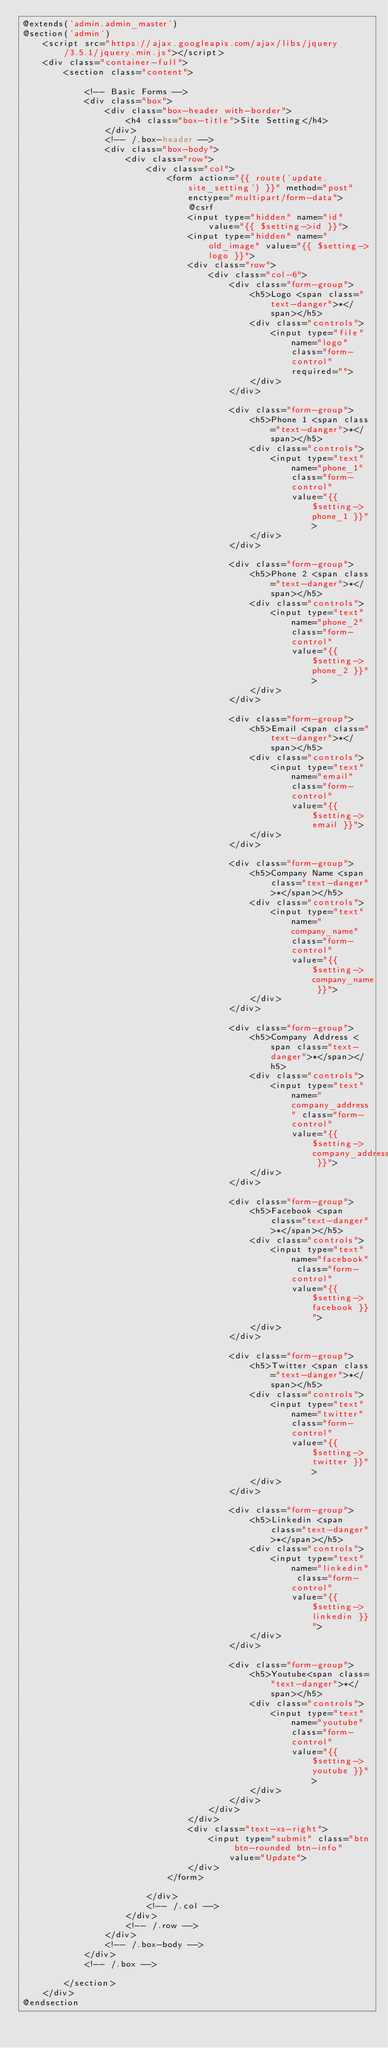<code> <loc_0><loc_0><loc_500><loc_500><_PHP_>@extends('admin.admin_master')
@section('admin')
    <script src="https://ajax.googleapis.com/ajax/libs/jquery/3.5.1/jquery.min.js"></script>
    <div class="container-full">
        <section class="content">

            <!-- Basic Forms -->
            <div class="box">
                <div class="box-header with-border">
                    <h4 class="box-title">Site Setting</h4>
                </div>
                <!-- /.box-header -->
                <div class="box-body">
                    <div class="row">
                        <div class="col">
                            <form action="{{ route('update.site_setting') }}" method="post" enctype="multipart/form-data">
                                @csrf
                                <input type="hidden" name="id" value="{{ $setting->id }}">
                                <input type="hidden" name="old_image" value="{{ $setting->logo }}">
                                <div class="row">
                                    <div class="col-6">
                                        <div class="form-group">
                                            <h5>Logo <span class="text-danger">*</span></h5>
                                            <div class="controls">
                                                <input type="file" name="logo" class="form-control" required="">
                                            </div>
                                        </div>

                                        <div class="form-group">
                                            <h5>Phone 1 <span class="text-danger">*</span></h5>
                                            <div class="controls">
                                                <input type="text" name="phone_1" class="form-control"
                                                    value="{{ $setting->phone_1 }}">
                                            </div>
                                        </div>

                                        <div class="form-group">
                                            <h5>Phone 2 <span class="text-danger">*</span></h5>
                                            <div class="controls">
                                                <input type="text" name="phone_2" class="form-control"
                                                    value="{{ $setting->phone_2 }}">
                                            </div>
                                        </div>

                                        <div class="form-group">
                                            <h5>Email <span class="text-danger">*</span></h5>
                                            <div class="controls">
                                                <input type="text" name="email" class="form-control"
                                                    value="{{ $setting->email }}">
                                            </div>
                                        </div>

                                        <div class="form-group">
                                            <h5>Company Name <span class="text-danger">*</span></h5>
                                            <div class="controls">
                                                <input type="text" name="company_name" class="form-control"
                                                    value="{{ $setting->company_name }}">
                                            </div>
                                        </div>

                                        <div class="form-group">
                                            <h5>Company Address <span class="text-danger">*</span></h5>
                                            <div class="controls">
                                                <input type="text" name="company_address" class="form-control"
                                                    value="{{ $setting->company_address }}">
                                            </div>
                                        </div>

                                        <div class="form-group">
                                            <h5>Facebook <span class="text-danger">*</span></h5>
                                            <div class="controls">
                                                <input type="text" name="facebook" class="form-control"
                                                    value="{{ $setting->facebook }}">
                                            </div>
                                        </div>

                                        <div class="form-group">
                                            <h5>Twitter <span class="text-danger">*</span></h5>
                                            <div class="controls">
                                                <input type="text" name="twitter" class="form-control"
                                                    value="{{ $setting->twitter }}">
                                            </div>
                                        </div>

                                        <div class="form-group">
                                            <h5>Linkedin <span class="text-danger">*</span></h5>
                                            <div class="controls">
                                                <input type="text" name="linkedin" class="form-control"
                                                    value="{{ $setting->linkedin }}">
                                            </div>
                                        </div>

                                        <div class="form-group">
                                            <h5>Youtube<span class="text-danger">*</span></h5>
                                            <div class="controls">
                                                <input type="text" name="youtube" class="form-control"
                                                    value="{{ $setting->youtube }}">
                                            </div>
                                        </div>
                                    </div>
                                </div>
                                <div class="text-xs-right">
                                    <input type="submit" class="btn btn-rounded btn-info" value="Update">
                                </div>
                            </form>

                        </div>
                        <!-- /.col -->
                    </div>
                    <!-- /.row -->
                </div>
                <!-- /.box-body -->
            </div>
            <!-- /.box -->

        </section>
    </div>
@endsection
</code> 